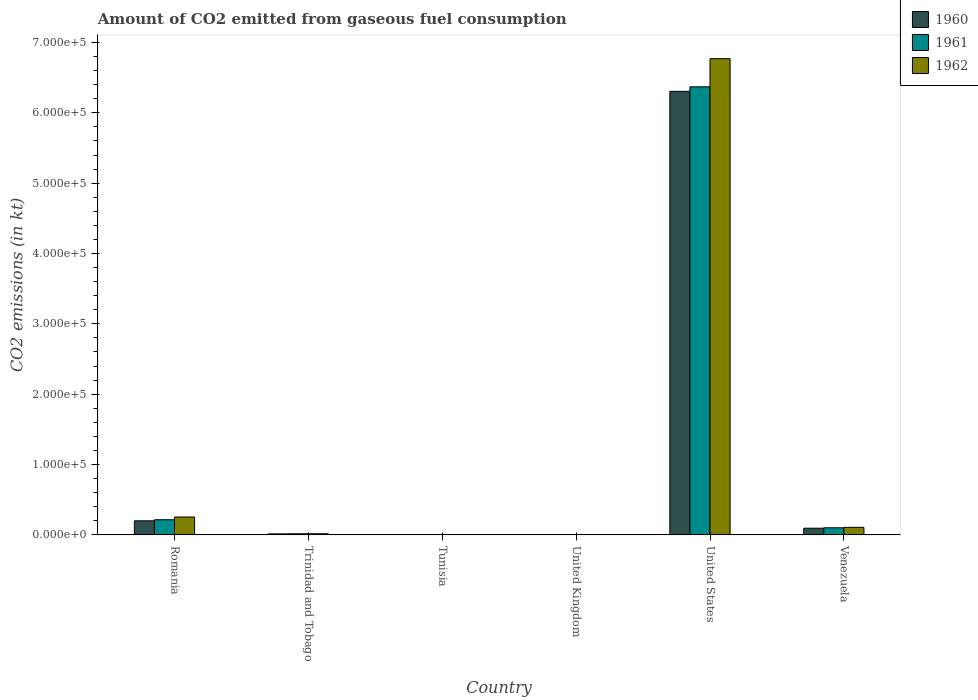How many groups of bars are there?
Your answer should be very brief. 6. Are the number of bars on each tick of the X-axis equal?
Provide a succinct answer. Yes. How many bars are there on the 1st tick from the left?
Give a very brief answer. 3. What is the label of the 3rd group of bars from the left?
Offer a terse response. Tunisia. In how many cases, is the number of bars for a given country not equal to the number of legend labels?
Your answer should be compact. 0. What is the amount of CO2 emitted in 1961 in Trinidad and Tobago?
Provide a short and direct response. 1595.14. Across all countries, what is the maximum amount of CO2 emitted in 1962?
Provide a succinct answer. 6.77e+05. Across all countries, what is the minimum amount of CO2 emitted in 1961?
Make the answer very short. 14.67. In which country was the amount of CO2 emitted in 1961 maximum?
Make the answer very short. United States. In which country was the amount of CO2 emitted in 1961 minimum?
Your answer should be compact. Tunisia. What is the total amount of CO2 emitted in 1962 in the graph?
Make the answer very short. 7.15e+05. What is the difference between the amount of CO2 emitted in 1960 in Romania and that in Trinidad and Tobago?
Your response must be concise. 1.86e+04. What is the difference between the amount of CO2 emitted in 1961 in Venezuela and the amount of CO2 emitted in 1962 in United States?
Your answer should be compact. -6.67e+05. What is the average amount of CO2 emitted in 1960 per country?
Provide a short and direct response. 1.10e+05. In how many countries, is the amount of CO2 emitted in 1961 greater than 40000 kt?
Make the answer very short. 1. What is the ratio of the amount of CO2 emitted in 1960 in Romania to that in United States?
Offer a terse response. 0.03. Is the amount of CO2 emitted in 1960 in United Kingdom less than that in United States?
Provide a succinct answer. Yes. Is the difference between the amount of CO2 emitted in 1961 in Romania and United States greater than the difference between the amount of CO2 emitted in 1960 in Romania and United States?
Provide a short and direct response. No. What is the difference between the highest and the second highest amount of CO2 emitted in 1960?
Your answer should be very brief. -6.11e+05. What is the difference between the highest and the lowest amount of CO2 emitted in 1962?
Provide a short and direct response. 6.77e+05. In how many countries, is the amount of CO2 emitted in 1960 greater than the average amount of CO2 emitted in 1960 taken over all countries?
Your answer should be compact. 1. Is the sum of the amount of CO2 emitted in 1961 in Tunisia and United States greater than the maximum amount of CO2 emitted in 1962 across all countries?
Offer a terse response. No. What does the 3rd bar from the right in United Kingdom represents?
Give a very brief answer. 1960. Is it the case that in every country, the sum of the amount of CO2 emitted in 1960 and amount of CO2 emitted in 1962 is greater than the amount of CO2 emitted in 1961?
Your answer should be very brief. Yes. How many bars are there?
Your answer should be compact. 18. Are the values on the major ticks of Y-axis written in scientific E-notation?
Provide a short and direct response. Yes. Does the graph contain grids?
Keep it short and to the point. No. How are the legend labels stacked?
Provide a succinct answer. Vertical. What is the title of the graph?
Provide a succinct answer. Amount of CO2 emitted from gaseous fuel consumption. Does "1975" appear as one of the legend labels in the graph?
Keep it short and to the point. No. What is the label or title of the Y-axis?
Provide a short and direct response. CO2 emissions (in kt). What is the CO2 emissions (in kt) in 1960 in Romania?
Provide a succinct answer. 2.00e+04. What is the CO2 emissions (in kt) of 1961 in Romania?
Your answer should be very brief. 2.16e+04. What is the CO2 emissions (in kt) of 1962 in Romania?
Give a very brief answer. 2.54e+04. What is the CO2 emissions (in kt) in 1960 in Trinidad and Tobago?
Offer a very short reply. 1466.8. What is the CO2 emissions (in kt) in 1961 in Trinidad and Tobago?
Offer a very short reply. 1595.14. What is the CO2 emissions (in kt) of 1962 in Trinidad and Tobago?
Make the answer very short. 1628.15. What is the CO2 emissions (in kt) of 1960 in Tunisia?
Your response must be concise. 14.67. What is the CO2 emissions (in kt) in 1961 in Tunisia?
Keep it short and to the point. 14.67. What is the CO2 emissions (in kt) in 1962 in Tunisia?
Keep it short and to the point. 14.67. What is the CO2 emissions (in kt) in 1960 in United Kingdom?
Offer a terse response. 150.35. What is the CO2 emissions (in kt) in 1961 in United Kingdom?
Your answer should be compact. 150.35. What is the CO2 emissions (in kt) of 1962 in United Kingdom?
Offer a very short reply. 216.35. What is the CO2 emissions (in kt) in 1960 in United States?
Give a very brief answer. 6.31e+05. What is the CO2 emissions (in kt) in 1961 in United States?
Offer a very short reply. 6.37e+05. What is the CO2 emissions (in kt) of 1962 in United States?
Your response must be concise. 6.77e+05. What is the CO2 emissions (in kt) in 1960 in Venezuela?
Your answer should be very brief. 9508.53. What is the CO2 emissions (in kt) in 1961 in Venezuela?
Your answer should be very brief. 1.01e+04. What is the CO2 emissions (in kt) of 1962 in Venezuela?
Offer a very short reply. 1.07e+04. Across all countries, what is the maximum CO2 emissions (in kt) of 1960?
Provide a succinct answer. 6.31e+05. Across all countries, what is the maximum CO2 emissions (in kt) of 1961?
Provide a succinct answer. 6.37e+05. Across all countries, what is the maximum CO2 emissions (in kt) of 1962?
Your answer should be compact. 6.77e+05. Across all countries, what is the minimum CO2 emissions (in kt) in 1960?
Your answer should be compact. 14.67. Across all countries, what is the minimum CO2 emissions (in kt) in 1961?
Your answer should be very brief. 14.67. Across all countries, what is the minimum CO2 emissions (in kt) of 1962?
Make the answer very short. 14.67. What is the total CO2 emissions (in kt) in 1960 in the graph?
Keep it short and to the point. 6.62e+05. What is the total CO2 emissions (in kt) of 1961 in the graph?
Offer a very short reply. 6.70e+05. What is the total CO2 emissions (in kt) of 1962 in the graph?
Keep it short and to the point. 7.15e+05. What is the difference between the CO2 emissions (in kt) of 1960 in Romania and that in Trinidad and Tobago?
Your response must be concise. 1.86e+04. What is the difference between the CO2 emissions (in kt) of 1961 in Romania and that in Trinidad and Tobago?
Give a very brief answer. 2.00e+04. What is the difference between the CO2 emissions (in kt) in 1962 in Romania and that in Trinidad and Tobago?
Your answer should be compact. 2.38e+04. What is the difference between the CO2 emissions (in kt) of 1960 in Romania and that in Tunisia?
Make the answer very short. 2.00e+04. What is the difference between the CO2 emissions (in kt) in 1961 in Romania and that in Tunisia?
Your answer should be compact. 2.15e+04. What is the difference between the CO2 emissions (in kt) in 1962 in Romania and that in Tunisia?
Keep it short and to the point. 2.54e+04. What is the difference between the CO2 emissions (in kt) of 1960 in Romania and that in United Kingdom?
Your response must be concise. 1.99e+04. What is the difference between the CO2 emissions (in kt) of 1961 in Romania and that in United Kingdom?
Provide a succinct answer. 2.14e+04. What is the difference between the CO2 emissions (in kt) of 1962 in Romania and that in United Kingdom?
Keep it short and to the point. 2.52e+04. What is the difference between the CO2 emissions (in kt) in 1960 in Romania and that in United States?
Ensure brevity in your answer.  -6.11e+05. What is the difference between the CO2 emissions (in kt) of 1961 in Romania and that in United States?
Ensure brevity in your answer.  -6.15e+05. What is the difference between the CO2 emissions (in kt) of 1962 in Romania and that in United States?
Give a very brief answer. -6.51e+05. What is the difference between the CO2 emissions (in kt) in 1960 in Romania and that in Venezuela?
Provide a succinct answer. 1.05e+04. What is the difference between the CO2 emissions (in kt) in 1961 in Romania and that in Venezuela?
Provide a succinct answer. 1.14e+04. What is the difference between the CO2 emissions (in kt) in 1962 in Romania and that in Venezuela?
Offer a terse response. 1.47e+04. What is the difference between the CO2 emissions (in kt) in 1960 in Trinidad and Tobago and that in Tunisia?
Your answer should be compact. 1452.13. What is the difference between the CO2 emissions (in kt) in 1961 in Trinidad and Tobago and that in Tunisia?
Your answer should be compact. 1580.48. What is the difference between the CO2 emissions (in kt) of 1962 in Trinidad and Tobago and that in Tunisia?
Give a very brief answer. 1613.48. What is the difference between the CO2 emissions (in kt) in 1960 in Trinidad and Tobago and that in United Kingdom?
Keep it short and to the point. 1316.45. What is the difference between the CO2 emissions (in kt) of 1961 in Trinidad and Tobago and that in United Kingdom?
Give a very brief answer. 1444.8. What is the difference between the CO2 emissions (in kt) in 1962 in Trinidad and Tobago and that in United Kingdom?
Your response must be concise. 1411.8. What is the difference between the CO2 emissions (in kt) in 1960 in Trinidad and Tobago and that in United States?
Give a very brief answer. -6.29e+05. What is the difference between the CO2 emissions (in kt) of 1961 in Trinidad and Tobago and that in United States?
Keep it short and to the point. -6.35e+05. What is the difference between the CO2 emissions (in kt) in 1962 in Trinidad and Tobago and that in United States?
Keep it short and to the point. -6.75e+05. What is the difference between the CO2 emissions (in kt) in 1960 in Trinidad and Tobago and that in Venezuela?
Provide a short and direct response. -8041.73. What is the difference between the CO2 emissions (in kt) in 1961 in Trinidad and Tobago and that in Venezuela?
Your answer should be very brief. -8525.77. What is the difference between the CO2 emissions (in kt) of 1962 in Trinidad and Tobago and that in Venezuela?
Offer a very short reply. -9072.16. What is the difference between the CO2 emissions (in kt) in 1960 in Tunisia and that in United Kingdom?
Keep it short and to the point. -135.68. What is the difference between the CO2 emissions (in kt) in 1961 in Tunisia and that in United Kingdom?
Offer a very short reply. -135.68. What is the difference between the CO2 emissions (in kt) of 1962 in Tunisia and that in United Kingdom?
Offer a terse response. -201.69. What is the difference between the CO2 emissions (in kt) of 1960 in Tunisia and that in United States?
Keep it short and to the point. -6.31e+05. What is the difference between the CO2 emissions (in kt) of 1961 in Tunisia and that in United States?
Your response must be concise. -6.37e+05. What is the difference between the CO2 emissions (in kt) in 1962 in Tunisia and that in United States?
Your answer should be compact. -6.77e+05. What is the difference between the CO2 emissions (in kt) in 1960 in Tunisia and that in Venezuela?
Your response must be concise. -9493.86. What is the difference between the CO2 emissions (in kt) in 1961 in Tunisia and that in Venezuela?
Make the answer very short. -1.01e+04. What is the difference between the CO2 emissions (in kt) in 1962 in Tunisia and that in Venezuela?
Give a very brief answer. -1.07e+04. What is the difference between the CO2 emissions (in kt) in 1960 in United Kingdom and that in United States?
Offer a very short reply. -6.30e+05. What is the difference between the CO2 emissions (in kt) in 1961 in United Kingdom and that in United States?
Give a very brief answer. -6.37e+05. What is the difference between the CO2 emissions (in kt) in 1962 in United Kingdom and that in United States?
Your response must be concise. -6.77e+05. What is the difference between the CO2 emissions (in kt) in 1960 in United Kingdom and that in Venezuela?
Provide a succinct answer. -9358.18. What is the difference between the CO2 emissions (in kt) of 1961 in United Kingdom and that in Venezuela?
Make the answer very short. -9970.57. What is the difference between the CO2 emissions (in kt) in 1962 in United Kingdom and that in Venezuela?
Ensure brevity in your answer.  -1.05e+04. What is the difference between the CO2 emissions (in kt) of 1960 in United States and that in Venezuela?
Make the answer very short. 6.21e+05. What is the difference between the CO2 emissions (in kt) in 1961 in United States and that in Venezuela?
Ensure brevity in your answer.  6.27e+05. What is the difference between the CO2 emissions (in kt) in 1962 in United States and that in Venezuela?
Your answer should be compact. 6.66e+05. What is the difference between the CO2 emissions (in kt) of 1960 in Romania and the CO2 emissions (in kt) of 1961 in Trinidad and Tobago?
Ensure brevity in your answer.  1.84e+04. What is the difference between the CO2 emissions (in kt) of 1960 in Romania and the CO2 emissions (in kt) of 1962 in Trinidad and Tobago?
Your answer should be very brief. 1.84e+04. What is the difference between the CO2 emissions (in kt) of 1961 in Romania and the CO2 emissions (in kt) of 1962 in Trinidad and Tobago?
Your answer should be compact. 1.99e+04. What is the difference between the CO2 emissions (in kt) in 1960 in Romania and the CO2 emissions (in kt) in 1961 in Tunisia?
Offer a very short reply. 2.00e+04. What is the difference between the CO2 emissions (in kt) in 1960 in Romania and the CO2 emissions (in kt) in 1962 in Tunisia?
Your answer should be compact. 2.00e+04. What is the difference between the CO2 emissions (in kt) of 1961 in Romania and the CO2 emissions (in kt) of 1962 in Tunisia?
Provide a succinct answer. 2.15e+04. What is the difference between the CO2 emissions (in kt) in 1960 in Romania and the CO2 emissions (in kt) in 1961 in United Kingdom?
Your answer should be very brief. 1.99e+04. What is the difference between the CO2 emissions (in kt) in 1960 in Romania and the CO2 emissions (in kt) in 1962 in United Kingdom?
Offer a terse response. 1.98e+04. What is the difference between the CO2 emissions (in kt) of 1961 in Romania and the CO2 emissions (in kt) of 1962 in United Kingdom?
Your answer should be very brief. 2.13e+04. What is the difference between the CO2 emissions (in kt) in 1960 in Romania and the CO2 emissions (in kt) in 1961 in United States?
Provide a short and direct response. -6.17e+05. What is the difference between the CO2 emissions (in kt) in 1960 in Romania and the CO2 emissions (in kt) in 1962 in United States?
Your answer should be compact. -6.57e+05. What is the difference between the CO2 emissions (in kt) of 1961 in Romania and the CO2 emissions (in kt) of 1962 in United States?
Your answer should be compact. -6.55e+05. What is the difference between the CO2 emissions (in kt) in 1960 in Romania and the CO2 emissions (in kt) in 1961 in Venezuela?
Provide a succinct answer. 9897.23. What is the difference between the CO2 emissions (in kt) of 1960 in Romania and the CO2 emissions (in kt) of 1962 in Venezuela?
Provide a succinct answer. 9317.85. What is the difference between the CO2 emissions (in kt) in 1961 in Romania and the CO2 emissions (in kt) in 1962 in Venezuela?
Give a very brief answer. 1.09e+04. What is the difference between the CO2 emissions (in kt) of 1960 in Trinidad and Tobago and the CO2 emissions (in kt) of 1961 in Tunisia?
Ensure brevity in your answer.  1452.13. What is the difference between the CO2 emissions (in kt) of 1960 in Trinidad and Tobago and the CO2 emissions (in kt) of 1962 in Tunisia?
Provide a succinct answer. 1452.13. What is the difference between the CO2 emissions (in kt) of 1961 in Trinidad and Tobago and the CO2 emissions (in kt) of 1962 in Tunisia?
Your answer should be very brief. 1580.48. What is the difference between the CO2 emissions (in kt) in 1960 in Trinidad and Tobago and the CO2 emissions (in kt) in 1961 in United Kingdom?
Your response must be concise. 1316.45. What is the difference between the CO2 emissions (in kt) of 1960 in Trinidad and Tobago and the CO2 emissions (in kt) of 1962 in United Kingdom?
Give a very brief answer. 1250.45. What is the difference between the CO2 emissions (in kt) in 1961 in Trinidad and Tobago and the CO2 emissions (in kt) in 1962 in United Kingdom?
Offer a very short reply. 1378.79. What is the difference between the CO2 emissions (in kt) of 1960 in Trinidad and Tobago and the CO2 emissions (in kt) of 1961 in United States?
Your answer should be very brief. -6.35e+05. What is the difference between the CO2 emissions (in kt) of 1960 in Trinidad and Tobago and the CO2 emissions (in kt) of 1962 in United States?
Give a very brief answer. -6.75e+05. What is the difference between the CO2 emissions (in kt) in 1961 in Trinidad and Tobago and the CO2 emissions (in kt) in 1962 in United States?
Ensure brevity in your answer.  -6.75e+05. What is the difference between the CO2 emissions (in kt) in 1960 in Trinidad and Tobago and the CO2 emissions (in kt) in 1961 in Venezuela?
Keep it short and to the point. -8654.12. What is the difference between the CO2 emissions (in kt) of 1960 in Trinidad and Tobago and the CO2 emissions (in kt) of 1962 in Venezuela?
Provide a short and direct response. -9233.51. What is the difference between the CO2 emissions (in kt) of 1961 in Trinidad and Tobago and the CO2 emissions (in kt) of 1962 in Venezuela?
Provide a short and direct response. -9105.16. What is the difference between the CO2 emissions (in kt) of 1960 in Tunisia and the CO2 emissions (in kt) of 1961 in United Kingdom?
Provide a succinct answer. -135.68. What is the difference between the CO2 emissions (in kt) in 1960 in Tunisia and the CO2 emissions (in kt) in 1962 in United Kingdom?
Provide a short and direct response. -201.69. What is the difference between the CO2 emissions (in kt) of 1961 in Tunisia and the CO2 emissions (in kt) of 1962 in United Kingdom?
Ensure brevity in your answer.  -201.69. What is the difference between the CO2 emissions (in kt) of 1960 in Tunisia and the CO2 emissions (in kt) of 1961 in United States?
Keep it short and to the point. -6.37e+05. What is the difference between the CO2 emissions (in kt) of 1960 in Tunisia and the CO2 emissions (in kt) of 1962 in United States?
Provide a succinct answer. -6.77e+05. What is the difference between the CO2 emissions (in kt) in 1961 in Tunisia and the CO2 emissions (in kt) in 1962 in United States?
Keep it short and to the point. -6.77e+05. What is the difference between the CO2 emissions (in kt) in 1960 in Tunisia and the CO2 emissions (in kt) in 1961 in Venezuela?
Provide a short and direct response. -1.01e+04. What is the difference between the CO2 emissions (in kt) in 1960 in Tunisia and the CO2 emissions (in kt) in 1962 in Venezuela?
Offer a very short reply. -1.07e+04. What is the difference between the CO2 emissions (in kt) of 1961 in Tunisia and the CO2 emissions (in kt) of 1962 in Venezuela?
Your answer should be very brief. -1.07e+04. What is the difference between the CO2 emissions (in kt) of 1960 in United Kingdom and the CO2 emissions (in kt) of 1961 in United States?
Give a very brief answer. -6.37e+05. What is the difference between the CO2 emissions (in kt) in 1960 in United Kingdom and the CO2 emissions (in kt) in 1962 in United States?
Offer a terse response. -6.77e+05. What is the difference between the CO2 emissions (in kt) in 1961 in United Kingdom and the CO2 emissions (in kt) in 1962 in United States?
Your answer should be compact. -6.77e+05. What is the difference between the CO2 emissions (in kt) in 1960 in United Kingdom and the CO2 emissions (in kt) in 1961 in Venezuela?
Provide a short and direct response. -9970.57. What is the difference between the CO2 emissions (in kt) of 1960 in United Kingdom and the CO2 emissions (in kt) of 1962 in Venezuela?
Offer a very short reply. -1.05e+04. What is the difference between the CO2 emissions (in kt) in 1961 in United Kingdom and the CO2 emissions (in kt) in 1962 in Venezuela?
Provide a succinct answer. -1.05e+04. What is the difference between the CO2 emissions (in kt) in 1960 in United States and the CO2 emissions (in kt) in 1961 in Venezuela?
Make the answer very short. 6.20e+05. What is the difference between the CO2 emissions (in kt) of 1960 in United States and the CO2 emissions (in kt) of 1962 in Venezuela?
Provide a short and direct response. 6.20e+05. What is the difference between the CO2 emissions (in kt) in 1961 in United States and the CO2 emissions (in kt) in 1962 in Venezuela?
Keep it short and to the point. 6.26e+05. What is the average CO2 emissions (in kt) of 1960 per country?
Keep it short and to the point. 1.10e+05. What is the average CO2 emissions (in kt) in 1961 per country?
Offer a terse response. 1.12e+05. What is the average CO2 emissions (in kt) of 1962 per country?
Provide a short and direct response. 1.19e+05. What is the difference between the CO2 emissions (in kt) in 1960 and CO2 emissions (in kt) in 1961 in Romania?
Make the answer very short. -1536.47. What is the difference between the CO2 emissions (in kt) in 1960 and CO2 emissions (in kt) in 1962 in Romania?
Your answer should be compact. -5408.82. What is the difference between the CO2 emissions (in kt) in 1961 and CO2 emissions (in kt) in 1962 in Romania?
Your answer should be compact. -3872.35. What is the difference between the CO2 emissions (in kt) in 1960 and CO2 emissions (in kt) in 1961 in Trinidad and Tobago?
Ensure brevity in your answer.  -128.34. What is the difference between the CO2 emissions (in kt) of 1960 and CO2 emissions (in kt) of 1962 in Trinidad and Tobago?
Your answer should be compact. -161.35. What is the difference between the CO2 emissions (in kt) of 1961 and CO2 emissions (in kt) of 1962 in Trinidad and Tobago?
Provide a short and direct response. -33. What is the difference between the CO2 emissions (in kt) in 1961 and CO2 emissions (in kt) in 1962 in Tunisia?
Keep it short and to the point. 0. What is the difference between the CO2 emissions (in kt) of 1960 and CO2 emissions (in kt) of 1961 in United Kingdom?
Give a very brief answer. 0. What is the difference between the CO2 emissions (in kt) of 1960 and CO2 emissions (in kt) of 1962 in United Kingdom?
Your answer should be compact. -66.01. What is the difference between the CO2 emissions (in kt) in 1961 and CO2 emissions (in kt) in 1962 in United Kingdom?
Offer a very short reply. -66.01. What is the difference between the CO2 emissions (in kt) in 1960 and CO2 emissions (in kt) in 1961 in United States?
Ensure brevity in your answer.  -6395.25. What is the difference between the CO2 emissions (in kt) in 1960 and CO2 emissions (in kt) in 1962 in United States?
Offer a terse response. -4.64e+04. What is the difference between the CO2 emissions (in kt) of 1961 and CO2 emissions (in kt) of 1962 in United States?
Offer a very short reply. -4.00e+04. What is the difference between the CO2 emissions (in kt) of 1960 and CO2 emissions (in kt) of 1961 in Venezuela?
Ensure brevity in your answer.  -612.39. What is the difference between the CO2 emissions (in kt) in 1960 and CO2 emissions (in kt) in 1962 in Venezuela?
Keep it short and to the point. -1191.78. What is the difference between the CO2 emissions (in kt) in 1961 and CO2 emissions (in kt) in 1962 in Venezuela?
Offer a terse response. -579.39. What is the ratio of the CO2 emissions (in kt) in 1960 in Romania to that in Trinidad and Tobago?
Give a very brief answer. 13.65. What is the ratio of the CO2 emissions (in kt) in 1961 in Romania to that in Trinidad and Tobago?
Give a very brief answer. 13.51. What is the ratio of the CO2 emissions (in kt) in 1962 in Romania to that in Trinidad and Tobago?
Provide a short and direct response. 15.62. What is the ratio of the CO2 emissions (in kt) in 1960 in Romania to that in Tunisia?
Offer a terse response. 1364.75. What is the ratio of the CO2 emissions (in kt) in 1961 in Romania to that in Tunisia?
Offer a very short reply. 1469.5. What is the ratio of the CO2 emissions (in kt) of 1962 in Romania to that in Tunisia?
Offer a terse response. 1733.5. What is the ratio of the CO2 emissions (in kt) of 1960 in Romania to that in United Kingdom?
Make the answer very short. 133.15. What is the ratio of the CO2 emissions (in kt) of 1961 in Romania to that in United Kingdom?
Offer a very short reply. 143.37. What is the ratio of the CO2 emissions (in kt) of 1962 in Romania to that in United Kingdom?
Offer a very short reply. 117.53. What is the ratio of the CO2 emissions (in kt) of 1960 in Romania to that in United States?
Offer a terse response. 0.03. What is the ratio of the CO2 emissions (in kt) in 1961 in Romania to that in United States?
Give a very brief answer. 0.03. What is the ratio of the CO2 emissions (in kt) of 1962 in Romania to that in United States?
Make the answer very short. 0.04. What is the ratio of the CO2 emissions (in kt) in 1960 in Romania to that in Venezuela?
Your response must be concise. 2.11. What is the ratio of the CO2 emissions (in kt) in 1961 in Romania to that in Venezuela?
Ensure brevity in your answer.  2.13. What is the ratio of the CO2 emissions (in kt) of 1962 in Romania to that in Venezuela?
Make the answer very short. 2.38. What is the ratio of the CO2 emissions (in kt) of 1960 in Trinidad and Tobago to that in Tunisia?
Offer a very short reply. 100. What is the ratio of the CO2 emissions (in kt) in 1961 in Trinidad and Tobago to that in Tunisia?
Your response must be concise. 108.75. What is the ratio of the CO2 emissions (in kt) of 1962 in Trinidad and Tobago to that in Tunisia?
Ensure brevity in your answer.  111. What is the ratio of the CO2 emissions (in kt) of 1960 in Trinidad and Tobago to that in United Kingdom?
Offer a terse response. 9.76. What is the ratio of the CO2 emissions (in kt) of 1961 in Trinidad and Tobago to that in United Kingdom?
Offer a very short reply. 10.61. What is the ratio of the CO2 emissions (in kt) of 1962 in Trinidad and Tobago to that in United Kingdom?
Provide a short and direct response. 7.53. What is the ratio of the CO2 emissions (in kt) of 1960 in Trinidad and Tobago to that in United States?
Your answer should be compact. 0. What is the ratio of the CO2 emissions (in kt) in 1961 in Trinidad and Tobago to that in United States?
Provide a short and direct response. 0. What is the ratio of the CO2 emissions (in kt) of 1962 in Trinidad and Tobago to that in United States?
Your answer should be very brief. 0. What is the ratio of the CO2 emissions (in kt) in 1960 in Trinidad and Tobago to that in Venezuela?
Offer a very short reply. 0.15. What is the ratio of the CO2 emissions (in kt) in 1961 in Trinidad and Tobago to that in Venezuela?
Offer a very short reply. 0.16. What is the ratio of the CO2 emissions (in kt) in 1962 in Trinidad and Tobago to that in Venezuela?
Make the answer very short. 0.15. What is the ratio of the CO2 emissions (in kt) of 1960 in Tunisia to that in United Kingdom?
Offer a terse response. 0.1. What is the ratio of the CO2 emissions (in kt) of 1961 in Tunisia to that in United Kingdom?
Offer a very short reply. 0.1. What is the ratio of the CO2 emissions (in kt) in 1962 in Tunisia to that in United Kingdom?
Ensure brevity in your answer.  0.07. What is the ratio of the CO2 emissions (in kt) of 1961 in Tunisia to that in United States?
Keep it short and to the point. 0. What is the ratio of the CO2 emissions (in kt) in 1960 in Tunisia to that in Venezuela?
Provide a short and direct response. 0. What is the ratio of the CO2 emissions (in kt) of 1961 in Tunisia to that in Venezuela?
Give a very brief answer. 0. What is the ratio of the CO2 emissions (in kt) in 1962 in Tunisia to that in Venezuela?
Provide a succinct answer. 0. What is the ratio of the CO2 emissions (in kt) of 1960 in United Kingdom to that in Venezuela?
Provide a succinct answer. 0.02. What is the ratio of the CO2 emissions (in kt) in 1961 in United Kingdom to that in Venezuela?
Give a very brief answer. 0.01. What is the ratio of the CO2 emissions (in kt) of 1962 in United Kingdom to that in Venezuela?
Give a very brief answer. 0.02. What is the ratio of the CO2 emissions (in kt) of 1960 in United States to that in Venezuela?
Give a very brief answer. 66.31. What is the ratio of the CO2 emissions (in kt) of 1961 in United States to that in Venezuela?
Offer a terse response. 62.93. What is the ratio of the CO2 emissions (in kt) in 1962 in United States to that in Venezuela?
Offer a very short reply. 63.26. What is the difference between the highest and the second highest CO2 emissions (in kt) in 1960?
Offer a terse response. 6.11e+05. What is the difference between the highest and the second highest CO2 emissions (in kt) in 1961?
Ensure brevity in your answer.  6.15e+05. What is the difference between the highest and the second highest CO2 emissions (in kt) in 1962?
Provide a succinct answer. 6.51e+05. What is the difference between the highest and the lowest CO2 emissions (in kt) of 1960?
Your answer should be very brief. 6.31e+05. What is the difference between the highest and the lowest CO2 emissions (in kt) of 1961?
Your answer should be compact. 6.37e+05. What is the difference between the highest and the lowest CO2 emissions (in kt) of 1962?
Ensure brevity in your answer.  6.77e+05. 